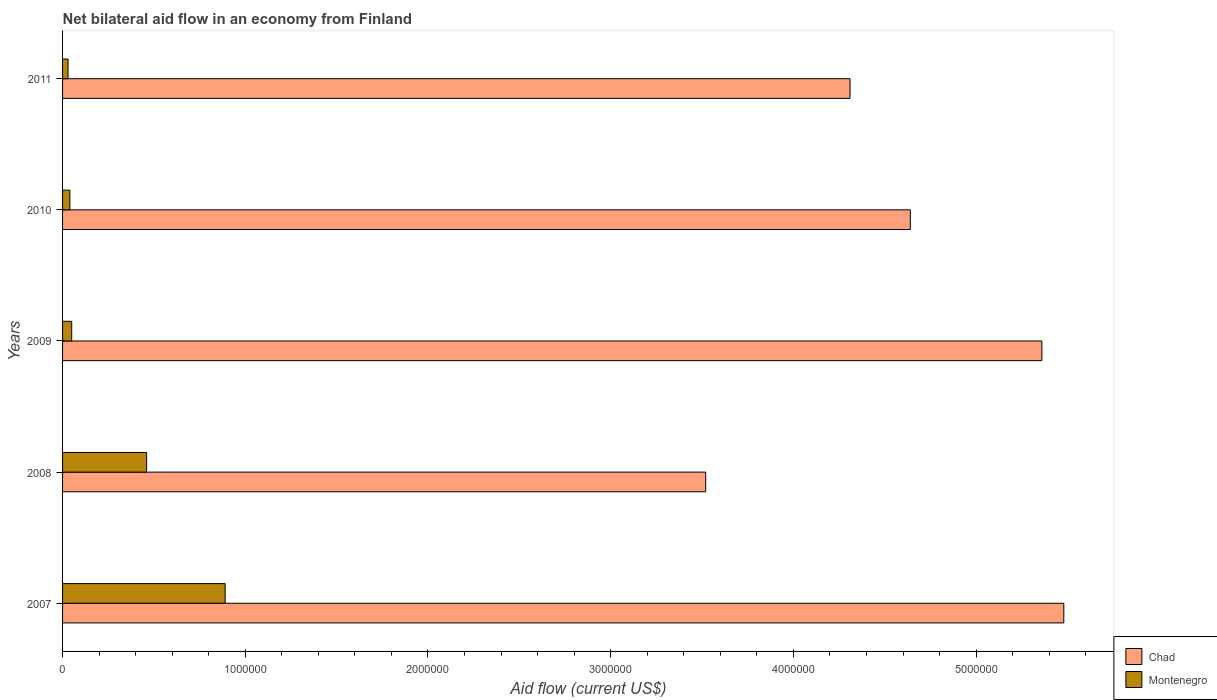How many groups of bars are there?
Ensure brevity in your answer.  5. Are the number of bars on each tick of the Y-axis equal?
Ensure brevity in your answer.  Yes. What is the label of the 5th group of bars from the top?
Your answer should be very brief. 2007. Across all years, what is the maximum net bilateral aid flow in Montenegro?
Provide a short and direct response. 8.90e+05. Across all years, what is the minimum net bilateral aid flow in Montenegro?
Your response must be concise. 3.00e+04. In which year was the net bilateral aid flow in Chad maximum?
Your answer should be very brief. 2007. In which year was the net bilateral aid flow in Chad minimum?
Ensure brevity in your answer.  2008. What is the total net bilateral aid flow in Montenegro in the graph?
Ensure brevity in your answer.  1.47e+06. What is the difference between the net bilateral aid flow in Montenegro in 2011 and the net bilateral aid flow in Chad in 2007?
Provide a succinct answer. -5.45e+06. What is the average net bilateral aid flow in Chad per year?
Offer a terse response. 4.66e+06. In the year 2008, what is the difference between the net bilateral aid flow in Chad and net bilateral aid flow in Montenegro?
Your answer should be compact. 3.06e+06. In how many years, is the net bilateral aid flow in Chad greater than 1200000 US$?
Your response must be concise. 5. What is the ratio of the net bilateral aid flow in Chad in 2008 to that in 2010?
Your response must be concise. 0.76. Is the net bilateral aid flow in Montenegro in 2010 less than that in 2011?
Make the answer very short. No. What is the difference between the highest and the lowest net bilateral aid flow in Montenegro?
Your response must be concise. 8.60e+05. In how many years, is the net bilateral aid flow in Chad greater than the average net bilateral aid flow in Chad taken over all years?
Your answer should be compact. 2. What does the 2nd bar from the top in 2010 represents?
Your answer should be very brief. Chad. What does the 1st bar from the bottom in 2011 represents?
Ensure brevity in your answer.  Chad. How many bars are there?
Your answer should be very brief. 10. Are all the bars in the graph horizontal?
Your answer should be very brief. Yes. What is the difference between two consecutive major ticks on the X-axis?
Provide a short and direct response. 1.00e+06. Where does the legend appear in the graph?
Keep it short and to the point. Bottom right. How many legend labels are there?
Offer a terse response. 2. What is the title of the graph?
Provide a succinct answer. Net bilateral aid flow in an economy from Finland. What is the label or title of the Y-axis?
Provide a succinct answer. Years. What is the Aid flow (current US$) of Chad in 2007?
Provide a succinct answer. 5.48e+06. What is the Aid flow (current US$) in Montenegro in 2007?
Make the answer very short. 8.90e+05. What is the Aid flow (current US$) of Chad in 2008?
Your answer should be very brief. 3.52e+06. What is the Aid flow (current US$) of Chad in 2009?
Offer a very short reply. 5.36e+06. What is the Aid flow (current US$) of Chad in 2010?
Your answer should be very brief. 4.64e+06. What is the Aid flow (current US$) of Montenegro in 2010?
Your response must be concise. 4.00e+04. What is the Aid flow (current US$) in Chad in 2011?
Give a very brief answer. 4.31e+06. Across all years, what is the maximum Aid flow (current US$) in Chad?
Your answer should be compact. 5.48e+06. Across all years, what is the maximum Aid flow (current US$) in Montenegro?
Offer a very short reply. 8.90e+05. Across all years, what is the minimum Aid flow (current US$) in Chad?
Offer a terse response. 3.52e+06. Across all years, what is the minimum Aid flow (current US$) in Montenegro?
Provide a succinct answer. 3.00e+04. What is the total Aid flow (current US$) in Chad in the graph?
Keep it short and to the point. 2.33e+07. What is the total Aid flow (current US$) in Montenegro in the graph?
Keep it short and to the point. 1.47e+06. What is the difference between the Aid flow (current US$) in Chad in 2007 and that in 2008?
Your response must be concise. 1.96e+06. What is the difference between the Aid flow (current US$) of Montenegro in 2007 and that in 2008?
Your response must be concise. 4.30e+05. What is the difference between the Aid flow (current US$) of Chad in 2007 and that in 2009?
Give a very brief answer. 1.20e+05. What is the difference between the Aid flow (current US$) of Montenegro in 2007 and that in 2009?
Ensure brevity in your answer.  8.40e+05. What is the difference between the Aid flow (current US$) in Chad in 2007 and that in 2010?
Give a very brief answer. 8.40e+05. What is the difference between the Aid flow (current US$) of Montenegro in 2007 and that in 2010?
Provide a short and direct response. 8.50e+05. What is the difference between the Aid flow (current US$) of Chad in 2007 and that in 2011?
Your answer should be compact. 1.17e+06. What is the difference between the Aid flow (current US$) of Montenegro in 2007 and that in 2011?
Provide a succinct answer. 8.60e+05. What is the difference between the Aid flow (current US$) of Chad in 2008 and that in 2009?
Keep it short and to the point. -1.84e+06. What is the difference between the Aid flow (current US$) of Montenegro in 2008 and that in 2009?
Your response must be concise. 4.10e+05. What is the difference between the Aid flow (current US$) in Chad in 2008 and that in 2010?
Provide a succinct answer. -1.12e+06. What is the difference between the Aid flow (current US$) in Montenegro in 2008 and that in 2010?
Ensure brevity in your answer.  4.20e+05. What is the difference between the Aid flow (current US$) in Chad in 2008 and that in 2011?
Give a very brief answer. -7.90e+05. What is the difference between the Aid flow (current US$) in Chad in 2009 and that in 2010?
Ensure brevity in your answer.  7.20e+05. What is the difference between the Aid flow (current US$) in Chad in 2009 and that in 2011?
Make the answer very short. 1.05e+06. What is the difference between the Aid flow (current US$) of Chad in 2010 and that in 2011?
Your response must be concise. 3.30e+05. What is the difference between the Aid flow (current US$) in Montenegro in 2010 and that in 2011?
Your answer should be compact. 10000. What is the difference between the Aid flow (current US$) in Chad in 2007 and the Aid flow (current US$) in Montenegro in 2008?
Keep it short and to the point. 5.02e+06. What is the difference between the Aid flow (current US$) in Chad in 2007 and the Aid flow (current US$) in Montenegro in 2009?
Your answer should be compact. 5.43e+06. What is the difference between the Aid flow (current US$) of Chad in 2007 and the Aid flow (current US$) of Montenegro in 2010?
Offer a terse response. 5.44e+06. What is the difference between the Aid flow (current US$) of Chad in 2007 and the Aid flow (current US$) of Montenegro in 2011?
Ensure brevity in your answer.  5.45e+06. What is the difference between the Aid flow (current US$) in Chad in 2008 and the Aid flow (current US$) in Montenegro in 2009?
Keep it short and to the point. 3.47e+06. What is the difference between the Aid flow (current US$) of Chad in 2008 and the Aid flow (current US$) of Montenegro in 2010?
Your response must be concise. 3.48e+06. What is the difference between the Aid flow (current US$) in Chad in 2008 and the Aid flow (current US$) in Montenegro in 2011?
Your response must be concise. 3.49e+06. What is the difference between the Aid flow (current US$) in Chad in 2009 and the Aid flow (current US$) in Montenegro in 2010?
Ensure brevity in your answer.  5.32e+06. What is the difference between the Aid flow (current US$) in Chad in 2009 and the Aid flow (current US$) in Montenegro in 2011?
Ensure brevity in your answer.  5.33e+06. What is the difference between the Aid flow (current US$) in Chad in 2010 and the Aid flow (current US$) in Montenegro in 2011?
Offer a terse response. 4.61e+06. What is the average Aid flow (current US$) in Chad per year?
Provide a succinct answer. 4.66e+06. What is the average Aid flow (current US$) in Montenegro per year?
Ensure brevity in your answer.  2.94e+05. In the year 2007, what is the difference between the Aid flow (current US$) of Chad and Aid flow (current US$) of Montenegro?
Provide a short and direct response. 4.59e+06. In the year 2008, what is the difference between the Aid flow (current US$) of Chad and Aid flow (current US$) of Montenegro?
Ensure brevity in your answer.  3.06e+06. In the year 2009, what is the difference between the Aid flow (current US$) of Chad and Aid flow (current US$) of Montenegro?
Your answer should be very brief. 5.31e+06. In the year 2010, what is the difference between the Aid flow (current US$) in Chad and Aid flow (current US$) in Montenegro?
Provide a short and direct response. 4.60e+06. In the year 2011, what is the difference between the Aid flow (current US$) of Chad and Aid flow (current US$) of Montenegro?
Your response must be concise. 4.28e+06. What is the ratio of the Aid flow (current US$) in Chad in 2007 to that in 2008?
Ensure brevity in your answer.  1.56. What is the ratio of the Aid flow (current US$) of Montenegro in 2007 to that in 2008?
Your answer should be compact. 1.93. What is the ratio of the Aid flow (current US$) of Chad in 2007 to that in 2009?
Provide a short and direct response. 1.02. What is the ratio of the Aid flow (current US$) in Montenegro in 2007 to that in 2009?
Offer a terse response. 17.8. What is the ratio of the Aid flow (current US$) of Chad in 2007 to that in 2010?
Offer a very short reply. 1.18. What is the ratio of the Aid flow (current US$) in Montenegro in 2007 to that in 2010?
Your response must be concise. 22.25. What is the ratio of the Aid flow (current US$) of Chad in 2007 to that in 2011?
Your answer should be compact. 1.27. What is the ratio of the Aid flow (current US$) in Montenegro in 2007 to that in 2011?
Offer a very short reply. 29.67. What is the ratio of the Aid flow (current US$) of Chad in 2008 to that in 2009?
Your answer should be compact. 0.66. What is the ratio of the Aid flow (current US$) of Chad in 2008 to that in 2010?
Offer a terse response. 0.76. What is the ratio of the Aid flow (current US$) in Chad in 2008 to that in 2011?
Your answer should be very brief. 0.82. What is the ratio of the Aid flow (current US$) of Montenegro in 2008 to that in 2011?
Make the answer very short. 15.33. What is the ratio of the Aid flow (current US$) in Chad in 2009 to that in 2010?
Your answer should be very brief. 1.16. What is the ratio of the Aid flow (current US$) of Montenegro in 2009 to that in 2010?
Your response must be concise. 1.25. What is the ratio of the Aid flow (current US$) of Chad in 2009 to that in 2011?
Offer a very short reply. 1.24. What is the ratio of the Aid flow (current US$) in Montenegro in 2009 to that in 2011?
Offer a very short reply. 1.67. What is the ratio of the Aid flow (current US$) in Chad in 2010 to that in 2011?
Your answer should be very brief. 1.08. What is the difference between the highest and the second highest Aid flow (current US$) of Chad?
Your answer should be very brief. 1.20e+05. What is the difference between the highest and the second highest Aid flow (current US$) of Montenegro?
Provide a succinct answer. 4.30e+05. What is the difference between the highest and the lowest Aid flow (current US$) of Chad?
Offer a terse response. 1.96e+06. What is the difference between the highest and the lowest Aid flow (current US$) in Montenegro?
Provide a short and direct response. 8.60e+05. 